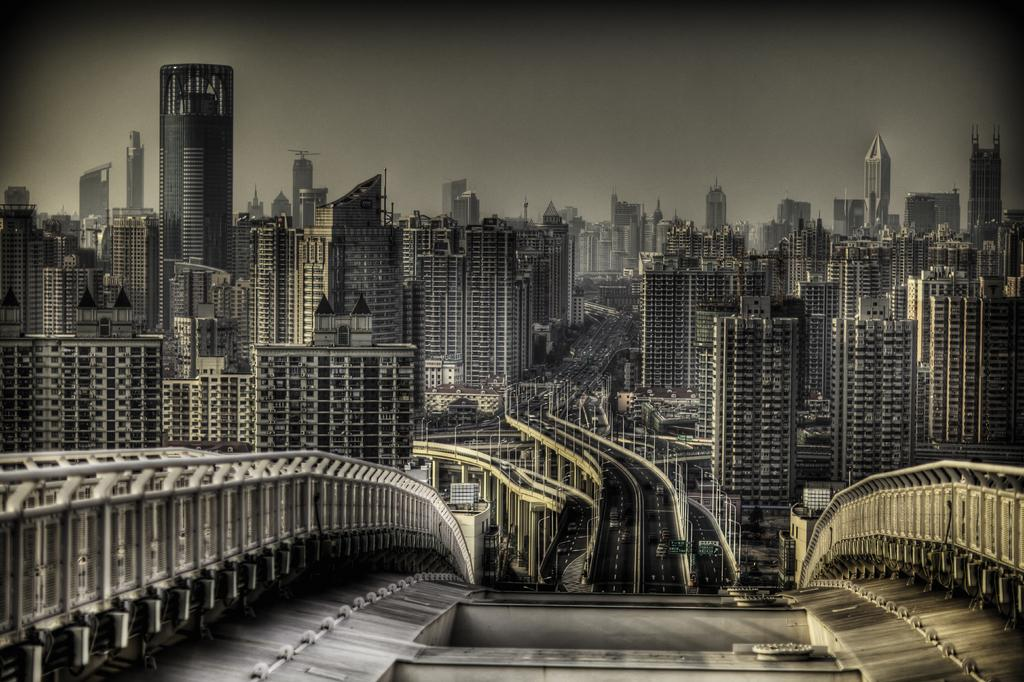What structure is the main subject of the image? There is a bridge in the image. What feature can be seen on both sides of the bridge? The bridge has a fence on both sides. What can be seen in the distance behind the bridge? There are vehicles and buildings visible in the background. What part of the natural environment is visible in the image? The sky is visible in the background. What type of cable can be seen connecting the bridge to the current in the image? There is no cable or current present in the image; it only features a bridge with a fence on both sides, vehicles and buildings in the background, and the sky visible in the background. 